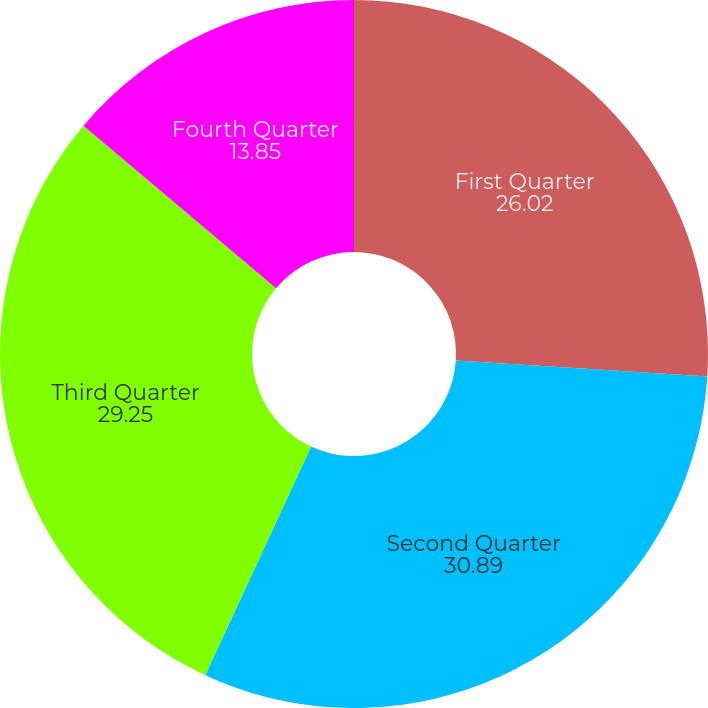Convert chart to OTSL. <chart><loc_0><loc_0><loc_500><loc_500><pie_chart><fcel>First Quarter<fcel>Second Quarter<fcel>Third Quarter<fcel>Fourth Quarter<nl><fcel>26.02%<fcel>30.89%<fcel>29.25%<fcel>13.85%<nl></chart> 